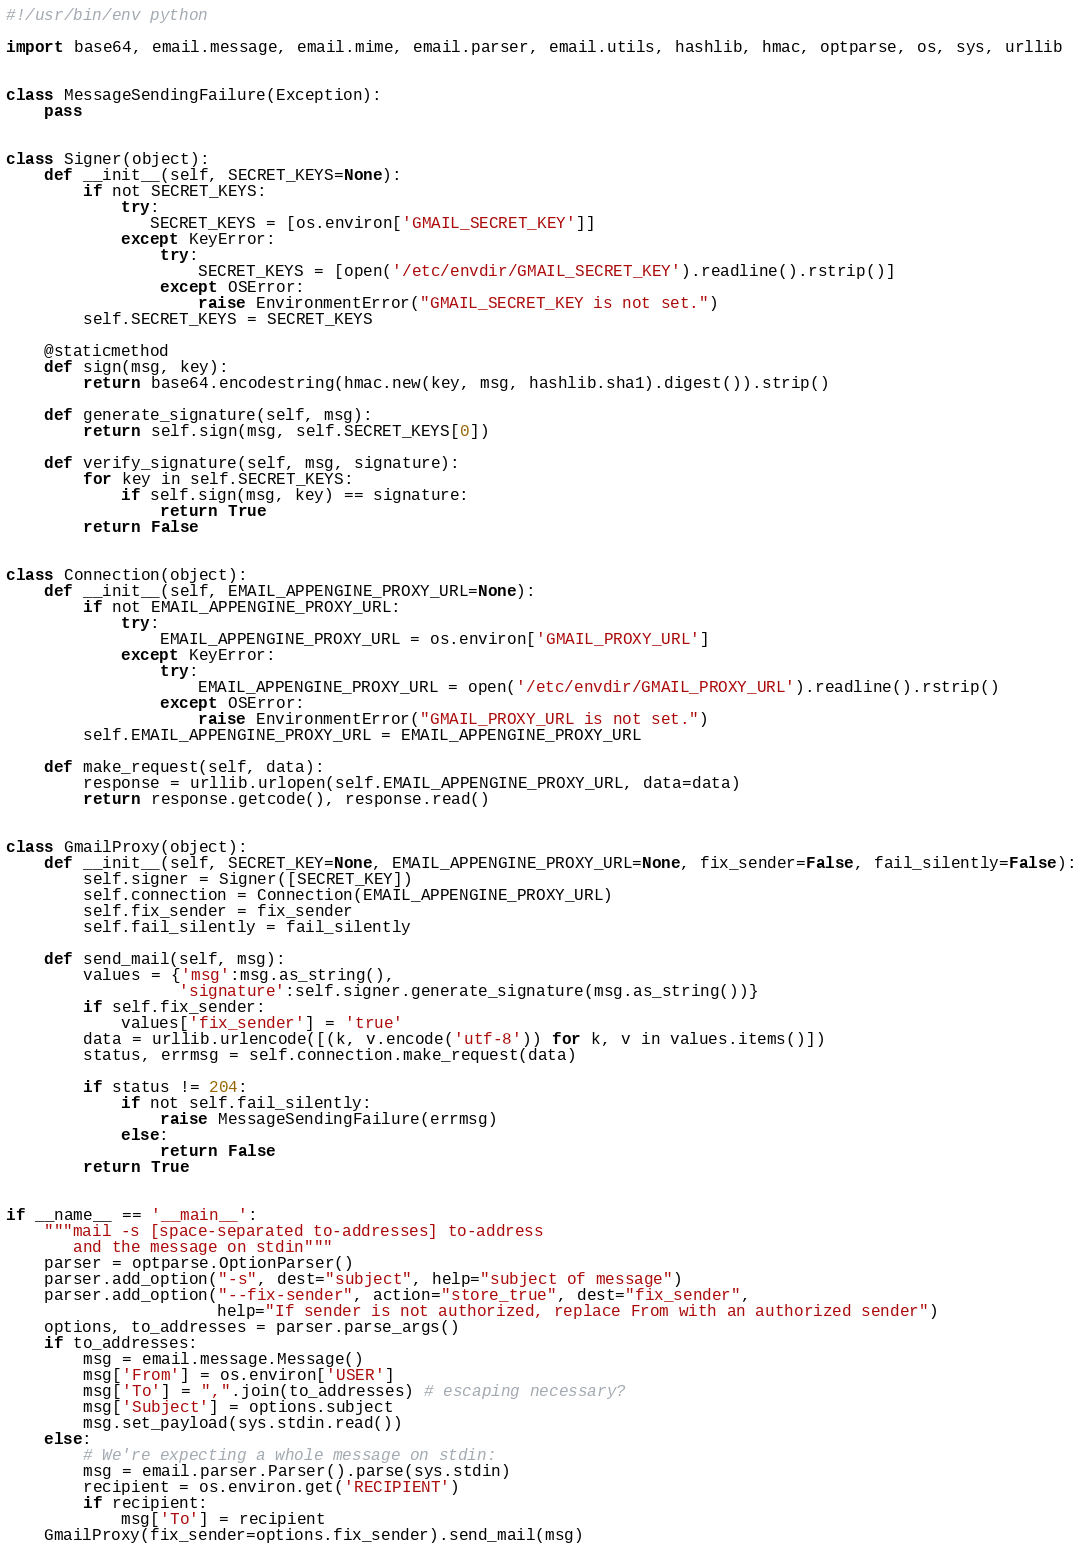<code> <loc_0><loc_0><loc_500><loc_500><_Python_>#!/usr/bin/env python

import base64, email.message, email.mime, email.parser, email.utils, hashlib, hmac, optparse, os, sys, urllib


class MessageSendingFailure(Exception):
    pass


class Signer(object):
    def __init__(self, SECRET_KEYS=None):
        if not SECRET_KEYS:
            try:
               SECRET_KEYS = [os.environ['GMAIL_SECRET_KEY']]
            except KeyError:
                try:
                    SECRET_KEYS = [open('/etc/envdir/GMAIL_SECRET_KEY').readline().rstrip()]
                except OSError:
                    raise EnvironmentError("GMAIL_SECRET_KEY is not set.")
        self.SECRET_KEYS = SECRET_KEYS

    @staticmethod
    def sign(msg, key):
        return base64.encodestring(hmac.new(key, msg, hashlib.sha1).digest()).strip()

    def generate_signature(self, msg):
        return self.sign(msg, self.SECRET_KEYS[0])

    def verify_signature(self, msg, signature):
        for key in self.SECRET_KEYS:
            if self.sign(msg, key) == signature:
                return True
        return False


class Connection(object):
    def __init__(self, EMAIL_APPENGINE_PROXY_URL=None):
        if not EMAIL_APPENGINE_PROXY_URL:
            try:
                EMAIL_APPENGINE_PROXY_URL = os.environ['GMAIL_PROXY_URL']
            except KeyError:
                try:
                    EMAIL_APPENGINE_PROXY_URL = open('/etc/envdir/GMAIL_PROXY_URL').readline().rstrip()
                except OSError:
                    raise EnvironmentError("GMAIL_PROXY_URL is not set.")
        self.EMAIL_APPENGINE_PROXY_URL = EMAIL_APPENGINE_PROXY_URL

    def make_request(self, data):
        response = urllib.urlopen(self.EMAIL_APPENGINE_PROXY_URL, data=data)
        return response.getcode(), response.read()


class GmailProxy(object):
    def __init__(self, SECRET_KEY=None, EMAIL_APPENGINE_PROXY_URL=None, fix_sender=False, fail_silently=False):
        self.signer = Signer([SECRET_KEY])
        self.connection = Connection(EMAIL_APPENGINE_PROXY_URL)
        self.fix_sender = fix_sender
        self.fail_silently = fail_silently

    def send_mail(self, msg):
        values = {'msg':msg.as_string(),
                  'signature':self.signer.generate_signature(msg.as_string())}
        if self.fix_sender:
            values['fix_sender'] = 'true'
        data = urllib.urlencode([(k, v.encode('utf-8')) for k, v in values.items()])
        status, errmsg = self.connection.make_request(data)

        if status != 204:
            if not self.fail_silently:
                raise MessageSendingFailure(errmsg)
            else:
                return False
        return True


if __name__ == '__main__':
    """mail -s [space-separated to-addresses] to-address
       and the message on stdin"""
    parser = optparse.OptionParser()
    parser.add_option("-s", dest="subject", help="subject of message")
    parser.add_option("--fix-sender", action="store_true", dest="fix_sender",
                      help="If sender is not authorized, replace From with an authorized sender")
    options, to_addresses = parser.parse_args()
    if to_addresses:
        msg = email.message.Message()
        msg['From'] = os.environ['USER']
        msg['To'] = ",".join(to_addresses) # escaping necessary?
        msg['Subject'] = options.subject
        msg.set_payload(sys.stdin.read())
    else:
        # We're expecting a whole message on stdin:
        msg = email.parser.Parser().parse(sys.stdin)
        recipient = os.environ.get('RECIPIENT')
        if recipient:
            msg['To'] = recipient
    GmailProxy(fix_sender=options.fix_sender).send_mail(msg)
</code> 